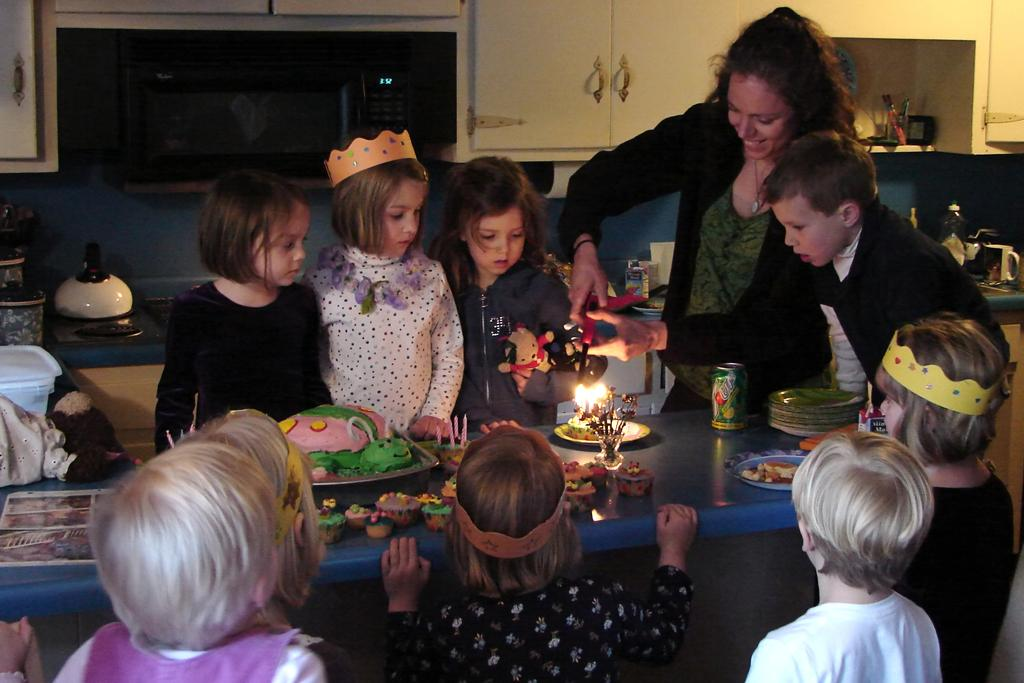What are the children doing in the image? The children are standing in a group. What is located in front of the children? There is a table in front of the children. What is on the table? There is a cake, tins, plates, and other objects on the table. Can you describe the objects visible at the back of the image? Unfortunately, the provided facts do not mention any objects visible at the back of the image. What type of fiction is being read by the children in the image? There is no indication in the image that the children are reading any fiction; they are standing in a group. 